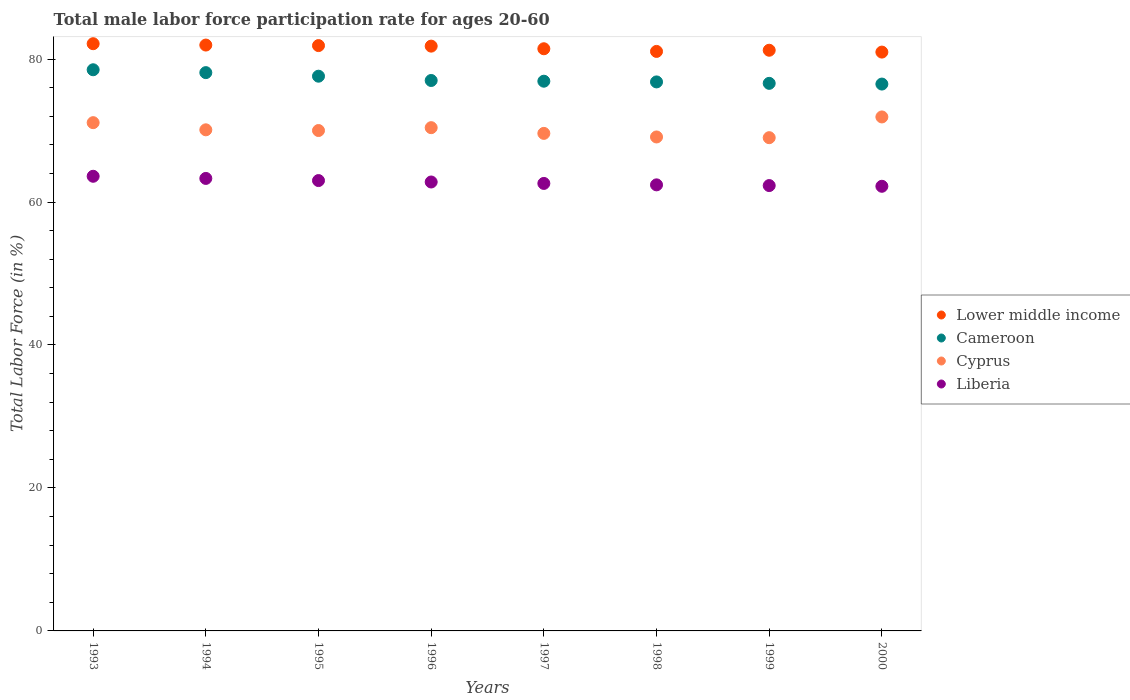What is the male labor force participation rate in Cyprus in 1996?
Make the answer very short. 70.4. Across all years, what is the maximum male labor force participation rate in Cyprus?
Provide a short and direct response. 71.9. Across all years, what is the minimum male labor force participation rate in Cyprus?
Offer a terse response. 69. What is the total male labor force participation rate in Liberia in the graph?
Provide a short and direct response. 502.2. What is the difference between the male labor force participation rate in Cyprus in 1996 and that in 1997?
Your answer should be compact. 0.8. What is the average male labor force participation rate in Cyprus per year?
Give a very brief answer. 70.15. In the year 1993, what is the difference between the male labor force participation rate in Cyprus and male labor force participation rate in Liberia?
Keep it short and to the point. 7.5. In how many years, is the male labor force participation rate in Lower middle income greater than 20 %?
Your answer should be compact. 8. What is the ratio of the male labor force participation rate in Cyprus in 1995 to that in 2000?
Ensure brevity in your answer.  0.97. Is the male labor force participation rate in Cyprus in 1996 less than that in 1998?
Your answer should be very brief. No. Is the difference between the male labor force participation rate in Cyprus in 1997 and 1998 greater than the difference between the male labor force participation rate in Liberia in 1997 and 1998?
Offer a very short reply. Yes. What is the difference between the highest and the second highest male labor force participation rate in Liberia?
Your answer should be very brief. 0.3. What is the difference between the highest and the lowest male labor force participation rate in Cameroon?
Offer a very short reply. 2. Is the sum of the male labor force participation rate in Liberia in 1993 and 1998 greater than the maximum male labor force participation rate in Cyprus across all years?
Provide a succinct answer. Yes. Does the male labor force participation rate in Lower middle income monotonically increase over the years?
Your answer should be compact. No. Is the male labor force participation rate in Liberia strictly greater than the male labor force participation rate in Cameroon over the years?
Your answer should be very brief. No. Is the male labor force participation rate in Lower middle income strictly less than the male labor force participation rate in Liberia over the years?
Make the answer very short. No. How many dotlines are there?
Provide a short and direct response. 4. Does the graph contain any zero values?
Give a very brief answer. No. Does the graph contain grids?
Keep it short and to the point. No. How many legend labels are there?
Ensure brevity in your answer.  4. What is the title of the graph?
Your answer should be compact. Total male labor force participation rate for ages 20-60. Does "Kuwait" appear as one of the legend labels in the graph?
Your answer should be very brief. No. What is the label or title of the X-axis?
Provide a succinct answer. Years. What is the Total Labor Force (in %) of Lower middle income in 1993?
Provide a short and direct response. 82.15. What is the Total Labor Force (in %) of Cameroon in 1993?
Your answer should be very brief. 78.5. What is the Total Labor Force (in %) in Cyprus in 1993?
Provide a short and direct response. 71.1. What is the Total Labor Force (in %) in Liberia in 1993?
Provide a succinct answer. 63.6. What is the Total Labor Force (in %) of Lower middle income in 1994?
Provide a short and direct response. 81.96. What is the Total Labor Force (in %) in Cameroon in 1994?
Your answer should be very brief. 78.1. What is the Total Labor Force (in %) of Cyprus in 1994?
Offer a terse response. 70.1. What is the Total Labor Force (in %) of Liberia in 1994?
Provide a short and direct response. 63.3. What is the Total Labor Force (in %) in Lower middle income in 1995?
Give a very brief answer. 81.88. What is the Total Labor Force (in %) in Cameroon in 1995?
Your answer should be compact. 77.6. What is the Total Labor Force (in %) in Lower middle income in 1996?
Offer a terse response. 81.81. What is the Total Labor Force (in %) of Cyprus in 1996?
Offer a very short reply. 70.4. What is the Total Labor Force (in %) in Liberia in 1996?
Your answer should be compact. 62.8. What is the Total Labor Force (in %) of Lower middle income in 1997?
Provide a short and direct response. 81.44. What is the Total Labor Force (in %) in Cameroon in 1997?
Your answer should be very brief. 76.9. What is the Total Labor Force (in %) in Cyprus in 1997?
Keep it short and to the point. 69.6. What is the Total Labor Force (in %) in Liberia in 1997?
Your answer should be very brief. 62.6. What is the Total Labor Force (in %) in Lower middle income in 1998?
Your answer should be compact. 81.07. What is the Total Labor Force (in %) in Cameroon in 1998?
Keep it short and to the point. 76.8. What is the Total Labor Force (in %) of Cyprus in 1998?
Make the answer very short. 69.1. What is the Total Labor Force (in %) in Liberia in 1998?
Provide a short and direct response. 62.4. What is the Total Labor Force (in %) of Lower middle income in 1999?
Your response must be concise. 81.23. What is the Total Labor Force (in %) of Cameroon in 1999?
Provide a succinct answer. 76.6. What is the Total Labor Force (in %) in Cyprus in 1999?
Give a very brief answer. 69. What is the Total Labor Force (in %) of Liberia in 1999?
Provide a succinct answer. 62.3. What is the Total Labor Force (in %) of Lower middle income in 2000?
Your answer should be very brief. 80.97. What is the Total Labor Force (in %) of Cameroon in 2000?
Offer a terse response. 76.5. What is the Total Labor Force (in %) in Cyprus in 2000?
Offer a very short reply. 71.9. What is the Total Labor Force (in %) in Liberia in 2000?
Your answer should be compact. 62.2. Across all years, what is the maximum Total Labor Force (in %) of Lower middle income?
Your answer should be very brief. 82.15. Across all years, what is the maximum Total Labor Force (in %) in Cameroon?
Your response must be concise. 78.5. Across all years, what is the maximum Total Labor Force (in %) of Cyprus?
Offer a terse response. 71.9. Across all years, what is the maximum Total Labor Force (in %) of Liberia?
Provide a succinct answer. 63.6. Across all years, what is the minimum Total Labor Force (in %) in Lower middle income?
Provide a succinct answer. 80.97. Across all years, what is the minimum Total Labor Force (in %) of Cameroon?
Ensure brevity in your answer.  76.5. Across all years, what is the minimum Total Labor Force (in %) in Cyprus?
Your response must be concise. 69. Across all years, what is the minimum Total Labor Force (in %) of Liberia?
Provide a short and direct response. 62.2. What is the total Total Labor Force (in %) of Lower middle income in the graph?
Your response must be concise. 652.5. What is the total Total Labor Force (in %) of Cameroon in the graph?
Offer a very short reply. 618. What is the total Total Labor Force (in %) in Cyprus in the graph?
Your answer should be compact. 561.2. What is the total Total Labor Force (in %) of Liberia in the graph?
Offer a very short reply. 502.2. What is the difference between the Total Labor Force (in %) of Lower middle income in 1993 and that in 1994?
Give a very brief answer. 0.19. What is the difference between the Total Labor Force (in %) in Cameroon in 1993 and that in 1994?
Keep it short and to the point. 0.4. What is the difference between the Total Labor Force (in %) of Cyprus in 1993 and that in 1994?
Ensure brevity in your answer.  1. What is the difference between the Total Labor Force (in %) in Lower middle income in 1993 and that in 1995?
Give a very brief answer. 0.26. What is the difference between the Total Labor Force (in %) of Cyprus in 1993 and that in 1995?
Keep it short and to the point. 1.1. What is the difference between the Total Labor Force (in %) in Liberia in 1993 and that in 1995?
Keep it short and to the point. 0.6. What is the difference between the Total Labor Force (in %) of Lower middle income in 1993 and that in 1996?
Give a very brief answer. 0.34. What is the difference between the Total Labor Force (in %) of Cameroon in 1993 and that in 1996?
Your response must be concise. 1.5. What is the difference between the Total Labor Force (in %) in Cyprus in 1993 and that in 1996?
Your response must be concise. 0.7. What is the difference between the Total Labor Force (in %) of Liberia in 1993 and that in 1996?
Ensure brevity in your answer.  0.8. What is the difference between the Total Labor Force (in %) in Lower middle income in 1993 and that in 1997?
Offer a very short reply. 0.71. What is the difference between the Total Labor Force (in %) in Lower middle income in 1993 and that in 1998?
Offer a terse response. 1.08. What is the difference between the Total Labor Force (in %) in Cameroon in 1993 and that in 1998?
Offer a very short reply. 1.7. What is the difference between the Total Labor Force (in %) of Cyprus in 1993 and that in 1998?
Provide a succinct answer. 2. What is the difference between the Total Labor Force (in %) in Liberia in 1993 and that in 1998?
Your answer should be compact. 1.2. What is the difference between the Total Labor Force (in %) in Lower middle income in 1993 and that in 1999?
Provide a succinct answer. 0.92. What is the difference between the Total Labor Force (in %) in Cameroon in 1993 and that in 1999?
Your answer should be compact. 1.9. What is the difference between the Total Labor Force (in %) of Cyprus in 1993 and that in 1999?
Provide a short and direct response. 2.1. What is the difference between the Total Labor Force (in %) in Lower middle income in 1993 and that in 2000?
Provide a succinct answer. 1.17. What is the difference between the Total Labor Force (in %) of Cyprus in 1993 and that in 2000?
Provide a short and direct response. -0.8. What is the difference between the Total Labor Force (in %) in Liberia in 1993 and that in 2000?
Offer a terse response. 1.4. What is the difference between the Total Labor Force (in %) of Lower middle income in 1994 and that in 1995?
Offer a very short reply. 0.07. What is the difference between the Total Labor Force (in %) in Liberia in 1994 and that in 1995?
Your answer should be compact. 0.3. What is the difference between the Total Labor Force (in %) in Lower middle income in 1994 and that in 1996?
Your answer should be very brief. 0.15. What is the difference between the Total Labor Force (in %) of Cameroon in 1994 and that in 1996?
Offer a very short reply. 1.1. What is the difference between the Total Labor Force (in %) in Lower middle income in 1994 and that in 1997?
Keep it short and to the point. 0.52. What is the difference between the Total Labor Force (in %) in Cyprus in 1994 and that in 1997?
Your answer should be compact. 0.5. What is the difference between the Total Labor Force (in %) of Lower middle income in 1994 and that in 1998?
Make the answer very short. 0.89. What is the difference between the Total Labor Force (in %) of Cyprus in 1994 and that in 1998?
Ensure brevity in your answer.  1. What is the difference between the Total Labor Force (in %) of Lower middle income in 1994 and that in 1999?
Your answer should be very brief. 0.73. What is the difference between the Total Labor Force (in %) in Cameroon in 1994 and that in 1999?
Provide a short and direct response. 1.5. What is the difference between the Total Labor Force (in %) of Lower middle income in 1994 and that in 2000?
Provide a succinct answer. 0.98. What is the difference between the Total Labor Force (in %) in Cyprus in 1994 and that in 2000?
Your answer should be very brief. -1.8. What is the difference between the Total Labor Force (in %) of Lower middle income in 1995 and that in 1996?
Offer a very short reply. 0.08. What is the difference between the Total Labor Force (in %) in Cyprus in 1995 and that in 1996?
Your response must be concise. -0.4. What is the difference between the Total Labor Force (in %) in Liberia in 1995 and that in 1996?
Your answer should be very brief. 0.2. What is the difference between the Total Labor Force (in %) of Lower middle income in 1995 and that in 1997?
Offer a terse response. 0.44. What is the difference between the Total Labor Force (in %) in Cameroon in 1995 and that in 1997?
Ensure brevity in your answer.  0.7. What is the difference between the Total Labor Force (in %) of Cyprus in 1995 and that in 1997?
Make the answer very short. 0.4. What is the difference between the Total Labor Force (in %) of Liberia in 1995 and that in 1997?
Provide a succinct answer. 0.4. What is the difference between the Total Labor Force (in %) of Lower middle income in 1995 and that in 1998?
Ensure brevity in your answer.  0.82. What is the difference between the Total Labor Force (in %) in Cyprus in 1995 and that in 1998?
Ensure brevity in your answer.  0.9. What is the difference between the Total Labor Force (in %) in Liberia in 1995 and that in 1998?
Your answer should be very brief. 0.6. What is the difference between the Total Labor Force (in %) in Lower middle income in 1995 and that in 1999?
Keep it short and to the point. 0.65. What is the difference between the Total Labor Force (in %) of Cameroon in 1995 and that in 1999?
Give a very brief answer. 1. What is the difference between the Total Labor Force (in %) of Liberia in 1995 and that in 1999?
Keep it short and to the point. 0.7. What is the difference between the Total Labor Force (in %) of Lower middle income in 1995 and that in 2000?
Your answer should be very brief. 0.91. What is the difference between the Total Labor Force (in %) of Cameroon in 1995 and that in 2000?
Make the answer very short. 1.1. What is the difference between the Total Labor Force (in %) of Cyprus in 1995 and that in 2000?
Your answer should be compact. -1.9. What is the difference between the Total Labor Force (in %) of Lower middle income in 1996 and that in 1997?
Your answer should be very brief. 0.37. What is the difference between the Total Labor Force (in %) of Liberia in 1996 and that in 1997?
Ensure brevity in your answer.  0.2. What is the difference between the Total Labor Force (in %) of Lower middle income in 1996 and that in 1998?
Make the answer very short. 0.74. What is the difference between the Total Labor Force (in %) in Cameroon in 1996 and that in 1998?
Provide a succinct answer. 0.2. What is the difference between the Total Labor Force (in %) in Cyprus in 1996 and that in 1998?
Offer a very short reply. 1.3. What is the difference between the Total Labor Force (in %) in Lower middle income in 1996 and that in 1999?
Provide a succinct answer. 0.58. What is the difference between the Total Labor Force (in %) of Cameroon in 1996 and that in 1999?
Offer a very short reply. 0.4. What is the difference between the Total Labor Force (in %) in Cyprus in 1996 and that in 1999?
Ensure brevity in your answer.  1.4. What is the difference between the Total Labor Force (in %) of Liberia in 1996 and that in 1999?
Make the answer very short. 0.5. What is the difference between the Total Labor Force (in %) in Lower middle income in 1996 and that in 2000?
Your response must be concise. 0.83. What is the difference between the Total Labor Force (in %) in Liberia in 1996 and that in 2000?
Offer a very short reply. 0.6. What is the difference between the Total Labor Force (in %) in Lower middle income in 1997 and that in 1998?
Offer a very short reply. 0.37. What is the difference between the Total Labor Force (in %) of Cameroon in 1997 and that in 1998?
Your answer should be very brief. 0.1. What is the difference between the Total Labor Force (in %) in Cyprus in 1997 and that in 1998?
Give a very brief answer. 0.5. What is the difference between the Total Labor Force (in %) in Lower middle income in 1997 and that in 1999?
Give a very brief answer. 0.21. What is the difference between the Total Labor Force (in %) in Cameroon in 1997 and that in 1999?
Keep it short and to the point. 0.3. What is the difference between the Total Labor Force (in %) of Liberia in 1997 and that in 1999?
Give a very brief answer. 0.3. What is the difference between the Total Labor Force (in %) of Lower middle income in 1997 and that in 2000?
Ensure brevity in your answer.  0.47. What is the difference between the Total Labor Force (in %) of Cameroon in 1997 and that in 2000?
Keep it short and to the point. 0.4. What is the difference between the Total Labor Force (in %) in Cyprus in 1997 and that in 2000?
Provide a succinct answer. -2.3. What is the difference between the Total Labor Force (in %) of Lower middle income in 1998 and that in 1999?
Ensure brevity in your answer.  -0.16. What is the difference between the Total Labor Force (in %) in Lower middle income in 1998 and that in 2000?
Keep it short and to the point. 0.09. What is the difference between the Total Labor Force (in %) of Cyprus in 1998 and that in 2000?
Offer a very short reply. -2.8. What is the difference between the Total Labor Force (in %) of Liberia in 1998 and that in 2000?
Keep it short and to the point. 0.2. What is the difference between the Total Labor Force (in %) in Lower middle income in 1999 and that in 2000?
Offer a very short reply. 0.26. What is the difference between the Total Labor Force (in %) in Cyprus in 1999 and that in 2000?
Make the answer very short. -2.9. What is the difference between the Total Labor Force (in %) of Lower middle income in 1993 and the Total Labor Force (in %) of Cameroon in 1994?
Offer a terse response. 4.05. What is the difference between the Total Labor Force (in %) in Lower middle income in 1993 and the Total Labor Force (in %) in Cyprus in 1994?
Ensure brevity in your answer.  12.05. What is the difference between the Total Labor Force (in %) of Lower middle income in 1993 and the Total Labor Force (in %) of Liberia in 1994?
Ensure brevity in your answer.  18.85. What is the difference between the Total Labor Force (in %) in Cameroon in 1993 and the Total Labor Force (in %) in Cyprus in 1994?
Your answer should be compact. 8.4. What is the difference between the Total Labor Force (in %) of Lower middle income in 1993 and the Total Labor Force (in %) of Cameroon in 1995?
Give a very brief answer. 4.55. What is the difference between the Total Labor Force (in %) in Lower middle income in 1993 and the Total Labor Force (in %) in Cyprus in 1995?
Keep it short and to the point. 12.15. What is the difference between the Total Labor Force (in %) in Lower middle income in 1993 and the Total Labor Force (in %) in Liberia in 1995?
Your response must be concise. 19.15. What is the difference between the Total Labor Force (in %) in Cameroon in 1993 and the Total Labor Force (in %) in Liberia in 1995?
Make the answer very short. 15.5. What is the difference between the Total Labor Force (in %) in Cyprus in 1993 and the Total Labor Force (in %) in Liberia in 1995?
Your answer should be compact. 8.1. What is the difference between the Total Labor Force (in %) in Lower middle income in 1993 and the Total Labor Force (in %) in Cameroon in 1996?
Ensure brevity in your answer.  5.15. What is the difference between the Total Labor Force (in %) of Lower middle income in 1993 and the Total Labor Force (in %) of Cyprus in 1996?
Offer a very short reply. 11.75. What is the difference between the Total Labor Force (in %) in Lower middle income in 1993 and the Total Labor Force (in %) in Liberia in 1996?
Your answer should be very brief. 19.35. What is the difference between the Total Labor Force (in %) in Cyprus in 1993 and the Total Labor Force (in %) in Liberia in 1996?
Provide a succinct answer. 8.3. What is the difference between the Total Labor Force (in %) of Lower middle income in 1993 and the Total Labor Force (in %) of Cameroon in 1997?
Offer a very short reply. 5.25. What is the difference between the Total Labor Force (in %) in Lower middle income in 1993 and the Total Labor Force (in %) in Cyprus in 1997?
Offer a terse response. 12.55. What is the difference between the Total Labor Force (in %) in Lower middle income in 1993 and the Total Labor Force (in %) in Liberia in 1997?
Your response must be concise. 19.55. What is the difference between the Total Labor Force (in %) in Lower middle income in 1993 and the Total Labor Force (in %) in Cameroon in 1998?
Provide a short and direct response. 5.35. What is the difference between the Total Labor Force (in %) of Lower middle income in 1993 and the Total Labor Force (in %) of Cyprus in 1998?
Your answer should be very brief. 13.05. What is the difference between the Total Labor Force (in %) of Lower middle income in 1993 and the Total Labor Force (in %) of Liberia in 1998?
Your response must be concise. 19.75. What is the difference between the Total Labor Force (in %) of Cameroon in 1993 and the Total Labor Force (in %) of Cyprus in 1998?
Your answer should be very brief. 9.4. What is the difference between the Total Labor Force (in %) of Cameroon in 1993 and the Total Labor Force (in %) of Liberia in 1998?
Your answer should be very brief. 16.1. What is the difference between the Total Labor Force (in %) of Cyprus in 1993 and the Total Labor Force (in %) of Liberia in 1998?
Offer a terse response. 8.7. What is the difference between the Total Labor Force (in %) in Lower middle income in 1993 and the Total Labor Force (in %) in Cameroon in 1999?
Ensure brevity in your answer.  5.55. What is the difference between the Total Labor Force (in %) in Lower middle income in 1993 and the Total Labor Force (in %) in Cyprus in 1999?
Provide a short and direct response. 13.15. What is the difference between the Total Labor Force (in %) of Lower middle income in 1993 and the Total Labor Force (in %) of Liberia in 1999?
Offer a very short reply. 19.85. What is the difference between the Total Labor Force (in %) of Cyprus in 1993 and the Total Labor Force (in %) of Liberia in 1999?
Keep it short and to the point. 8.8. What is the difference between the Total Labor Force (in %) of Lower middle income in 1993 and the Total Labor Force (in %) of Cameroon in 2000?
Offer a very short reply. 5.65. What is the difference between the Total Labor Force (in %) in Lower middle income in 1993 and the Total Labor Force (in %) in Cyprus in 2000?
Offer a very short reply. 10.25. What is the difference between the Total Labor Force (in %) of Lower middle income in 1993 and the Total Labor Force (in %) of Liberia in 2000?
Your answer should be very brief. 19.95. What is the difference between the Total Labor Force (in %) of Cameroon in 1993 and the Total Labor Force (in %) of Cyprus in 2000?
Your response must be concise. 6.6. What is the difference between the Total Labor Force (in %) of Cameroon in 1993 and the Total Labor Force (in %) of Liberia in 2000?
Make the answer very short. 16.3. What is the difference between the Total Labor Force (in %) of Cyprus in 1993 and the Total Labor Force (in %) of Liberia in 2000?
Ensure brevity in your answer.  8.9. What is the difference between the Total Labor Force (in %) of Lower middle income in 1994 and the Total Labor Force (in %) of Cameroon in 1995?
Offer a very short reply. 4.36. What is the difference between the Total Labor Force (in %) of Lower middle income in 1994 and the Total Labor Force (in %) of Cyprus in 1995?
Provide a short and direct response. 11.96. What is the difference between the Total Labor Force (in %) of Lower middle income in 1994 and the Total Labor Force (in %) of Liberia in 1995?
Give a very brief answer. 18.96. What is the difference between the Total Labor Force (in %) in Cameroon in 1994 and the Total Labor Force (in %) in Cyprus in 1995?
Ensure brevity in your answer.  8.1. What is the difference between the Total Labor Force (in %) in Lower middle income in 1994 and the Total Labor Force (in %) in Cameroon in 1996?
Offer a very short reply. 4.96. What is the difference between the Total Labor Force (in %) in Lower middle income in 1994 and the Total Labor Force (in %) in Cyprus in 1996?
Give a very brief answer. 11.56. What is the difference between the Total Labor Force (in %) of Lower middle income in 1994 and the Total Labor Force (in %) of Liberia in 1996?
Offer a terse response. 19.16. What is the difference between the Total Labor Force (in %) of Cyprus in 1994 and the Total Labor Force (in %) of Liberia in 1996?
Your response must be concise. 7.3. What is the difference between the Total Labor Force (in %) in Lower middle income in 1994 and the Total Labor Force (in %) in Cameroon in 1997?
Your response must be concise. 5.06. What is the difference between the Total Labor Force (in %) of Lower middle income in 1994 and the Total Labor Force (in %) of Cyprus in 1997?
Provide a short and direct response. 12.36. What is the difference between the Total Labor Force (in %) in Lower middle income in 1994 and the Total Labor Force (in %) in Liberia in 1997?
Your response must be concise. 19.36. What is the difference between the Total Labor Force (in %) in Cyprus in 1994 and the Total Labor Force (in %) in Liberia in 1997?
Make the answer very short. 7.5. What is the difference between the Total Labor Force (in %) of Lower middle income in 1994 and the Total Labor Force (in %) of Cameroon in 1998?
Make the answer very short. 5.16. What is the difference between the Total Labor Force (in %) of Lower middle income in 1994 and the Total Labor Force (in %) of Cyprus in 1998?
Your answer should be compact. 12.86. What is the difference between the Total Labor Force (in %) of Lower middle income in 1994 and the Total Labor Force (in %) of Liberia in 1998?
Offer a very short reply. 19.56. What is the difference between the Total Labor Force (in %) in Cameroon in 1994 and the Total Labor Force (in %) in Cyprus in 1998?
Ensure brevity in your answer.  9. What is the difference between the Total Labor Force (in %) in Lower middle income in 1994 and the Total Labor Force (in %) in Cameroon in 1999?
Offer a very short reply. 5.36. What is the difference between the Total Labor Force (in %) of Lower middle income in 1994 and the Total Labor Force (in %) of Cyprus in 1999?
Provide a short and direct response. 12.96. What is the difference between the Total Labor Force (in %) in Lower middle income in 1994 and the Total Labor Force (in %) in Liberia in 1999?
Provide a short and direct response. 19.66. What is the difference between the Total Labor Force (in %) in Cameroon in 1994 and the Total Labor Force (in %) in Liberia in 1999?
Make the answer very short. 15.8. What is the difference between the Total Labor Force (in %) of Cyprus in 1994 and the Total Labor Force (in %) of Liberia in 1999?
Ensure brevity in your answer.  7.8. What is the difference between the Total Labor Force (in %) in Lower middle income in 1994 and the Total Labor Force (in %) in Cameroon in 2000?
Your response must be concise. 5.46. What is the difference between the Total Labor Force (in %) of Lower middle income in 1994 and the Total Labor Force (in %) of Cyprus in 2000?
Provide a short and direct response. 10.06. What is the difference between the Total Labor Force (in %) of Lower middle income in 1994 and the Total Labor Force (in %) of Liberia in 2000?
Offer a very short reply. 19.76. What is the difference between the Total Labor Force (in %) of Cameroon in 1994 and the Total Labor Force (in %) of Cyprus in 2000?
Provide a short and direct response. 6.2. What is the difference between the Total Labor Force (in %) in Cameroon in 1994 and the Total Labor Force (in %) in Liberia in 2000?
Your response must be concise. 15.9. What is the difference between the Total Labor Force (in %) in Cyprus in 1994 and the Total Labor Force (in %) in Liberia in 2000?
Provide a short and direct response. 7.9. What is the difference between the Total Labor Force (in %) of Lower middle income in 1995 and the Total Labor Force (in %) of Cameroon in 1996?
Provide a succinct answer. 4.88. What is the difference between the Total Labor Force (in %) in Lower middle income in 1995 and the Total Labor Force (in %) in Cyprus in 1996?
Provide a succinct answer. 11.48. What is the difference between the Total Labor Force (in %) in Lower middle income in 1995 and the Total Labor Force (in %) in Liberia in 1996?
Keep it short and to the point. 19.08. What is the difference between the Total Labor Force (in %) in Cyprus in 1995 and the Total Labor Force (in %) in Liberia in 1996?
Your answer should be very brief. 7.2. What is the difference between the Total Labor Force (in %) in Lower middle income in 1995 and the Total Labor Force (in %) in Cameroon in 1997?
Your answer should be very brief. 4.98. What is the difference between the Total Labor Force (in %) in Lower middle income in 1995 and the Total Labor Force (in %) in Cyprus in 1997?
Ensure brevity in your answer.  12.28. What is the difference between the Total Labor Force (in %) in Lower middle income in 1995 and the Total Labor Force (in %) in Liberia in 1997?
Your answer should be very brief. 19.28. What is the difference between the Total Labor Force (in %) of Cameroon in 1995 and the Total Labor Force (in %) of Liberia in 1997?
Your answer should be compact. 15. What is the difference between the Total Labor Force (in %) in Cyprus in 1995 and the Total Labor Force (in %) in Liberia in 1997?
Ensure brevity in your answer.  7.4. What is the difference between the Total Labor Force (in %) of Lower middle income in 1995 and the Total Labor Force (in %) of Cameroon in 1998?
Keep it short and to the point. 5.08. What is the difference between the Total Labor Force (in %) in Lower middle income in 1995 and the Total Labor Force (in %) in Cyprus in 1998?
Your answer should be very brief. 12.78. What is the difference between the Total Labor Force (in %) in Lower middle income in 1995 and the Total Labor Force (in %) in Liberia in 1998?
Keep it short and to the point. 19.48. What is the difference between the Total Labor Force (in %) in Cameroon in 1995 and the Total Labor Force (in %) in Cyprus in 1998?
Keep it short and to the point. 8.5. What is the difference between the Total Labor Force (in %) in Lower middle income in 1995 and the Total Labor Force (in %) in Cameroon in 1999?
Give a very brief answer. 5.28. What is the difference between the Total Labor Force (in %) of Lower middle income in 1995 and the Total Labor Force (in %) of Cyprus in 1999?
Keep it short and to the point. 12.88. What is the difference between the Total Labor Force (in %) in Lower middle income in 1995 and the Total Labor Force (in %) in Liberia in 1999?
Your answer should be very brief. 19.58. What is the difference between the Total Labor Force (in %) of Cameroon in 1995 and the Total Labor Force (in %) of Cyprus in 1999?
Give a very brief answer. 8.6. What is the difference between the Total Labor Force (in %) of Cameroon in 1995 and the Total Labor Force (in %) of Liberia in 1999?
Give a very brief answer. 15.3. What is the difference between the Total Labor Force (in %) of Lower middle income in 1995 and the Total Labor Force (in %) of Cameroon in 2000?
Provide a short and direct response. 5.38. What is the difference between the Total Labor Force (in %) of Lower middle income in 1995 and the Total Labor Force (in %) of Cyprus in 2000?
Ensure brevity in your answer.  9.98. What is the difference between the Total Labor Force (in %) in Lower middle income in 1995 and the Total Labor Force (in %) in Liberia in 2000?
Provide a short and direct response. 19.68. What is the difference between the Total Labor Force (in %) in Cameroon in 1995 and the Total Labor Force (in %) in Cyprus in 2000?
Provide a succinct answer. 5.7. What is the difference between the Total Labor Force (in %) of Cameroon in 1995 and the Total Labor Force (in %) of Liberia in 2000?
Ensure brevity in your answer.  15.4. What is the difference between the Total Labor Force (in %) in Lower middle income in 1996 and the Total Labor Force (in %) in Cameroon in 1997?
Your answer should be compact. 4.91. What is the difference between the Total Labor Force (in %) of Lower middle income in 1996 and the Total Labor Force (in %) of Cyprus in 1997?
Your response must be concise. 12.21. What is the difference between the Total Labor Force (in %) of Lower middle income in 1996 and the Total Labor Force (in %) of Liberia in 1997?
Your answer should be compact. 19.21. What is the difference between the Total Labor Force (in %) of Cameroon in 1996 and the Total Labor Force (in %) of Cyprus in 1997?
Ensure brevity in your answer.  7.4. What is the difference between the Total Labor Force (in %) of Cameroon in 1996 and the Total Labor Force (in %) of Liberia in 1997?
Offer a terse response. 14.4. What is the difference between the Total Labor Force (in %) of Cyprus in 1996 and the Total Labor Force (in %) of Liberia in 1997?
Provide a succinct answer. 7.8. What is the difference between the Total Labor Force (in %) of Lower middle income in 1996 and the Total Labor Force (in %) of Cameroon in 1998?
Provide a succinct answer. 5.01. What is the difference between the Total Labor Force (in %) of Lower middle income in 1996 and the Total Labor Force (in %) of Cyprus in 1998?
Give a very brief answer. 12.71. What is the difference between the Total Labor Force (in %) in Lower middle income in 1996 and the Total Labor Force (in %) in Liberia in 1998?
Offer a terse response. 19.41. What is the difference between the Total Labor Force (in %) of Cameroon in 1996 and the Total Labor Force (in %) of Cyprus in 1998?
Provide a short and direct response. 7.9. What is the difference between the Total Labor Force (in %) of Lower middle income in 1996 and the Total Labor Force (in %) of Cameroon in 1999?
Your answer should be very brief. 5.21. What is the difference between the Total Labor Force (in %) of Lower middle income in 1996 and the Total Labor Force (in %) of Cyprus in 1999?
Provide a succinct answer. 12.81. What is the difference between the Total Labor Force (in %) in Lower middle income in 1996 and the Total Labor Force (in %) in Liberia in 1999?
Ensure brevity in your answer.  19.51. What is the difference between the Total Labor Force (in %) in Cameroon in 1996 and the Total Labor Force (in %) in Cyprus in 1999?
Give a very brief answer. 8. What is the difference between the Total Labor Force (in %) of Cameroon in 1996 and the Total Labor Force (in %) of Liberia in 1999?
Your response must be concise. 14.7. What is the difference between the Total Labor Force (in %) of Cyprus in 1996 and the Total Labor Force (in %) of Liberia in 1999?
Keep it short and to the point. 8.1. What is the difference between the Total Labor Force (in %) in Lower middle income in 1996 and the Total Labor Force (in %) in Cameroon in 2000?
Your answer should be very brief. 5.31. What is the difference between the Total Labor Force (in %) of Lower middle income in 1996 and the Total Labor Force (in %) of Cyprus in 2000?
Your answer should be very brief. 9.91. What is the difference between the Total Labor Force (in %) of Lower middle income in 1996 and the Total Labor Force (in %) of Liberia in 2000?
Keep it short and to the point. 19.61. What is the difference between the Total Labor Force (in %) of Cameroon in 1996 and the Total Labor Force (in %) of Cyprus in 2000?
Ensure brevity in your answer.  5.1. What is the difference between the Total Labor Force (in %) in Cameroon in 1996 and the Total Labor Force (in %) in Liberia in 2000?
Your answer should be compact. 14.8. What is the difference between the Total Labor Force (in %) in Cyprus in 1996 and the Total Labor Force (in %) in Liberia in 2000?
Keep it short and to the point. 8.2. What is the difference between the Total Labor Force (in %) in Lower middle income in 1997 and the Total Labor Force (in %) in Cameroon in 1998?
Your answer should be very brief. 4.64. What is the difference between the Total Labor Force (in %) of Lower middle income in 1997 and the Total Labor Force (in %) of Cyprus in 1998?
Offer a very short reply. 12.34. What is the difference between the Total Labor Force (in %) of Lower middle income in 1997 and the Total Labor Force (in %) of Liberia in 1998?
Ensure brevity in your answer.  19.04. What is the difference between the Total Labor Force (in %) of Cameroon in 1997 and the Total Labor Force (in %) of Cyprus in 1998?
Offer a very short reply. 7.8. What is the difference between the Total Labor Force (in %) of Cameroon in 1997 and the Total Labor Force (in %) of Liberia in 1998?
Make the answer very short. 14.5. What is the difference between the Total Labor Force (in %) of Lower middle income in 1997 and the Total Labor Force (in %) of Cameroon in 1999?
Offer a very short reply. 4.84. What is the difference between the Total Labor Force (in %) of Lower middle income in 1997 and the Total Labor Force (in %) of Cyprus in 1999?
Your response must be concise. 12.44. What is the difference between the Total Labor Force (in %) in Lower middle income in 1997 and the Total Labor Force (in %) in Liberia in 1999?
Offer a terse response. 19.14. What is the difference between the Total Labor Force (in %) in Cameroon in 1997 and the Total Labor Force (in %) in Liberia in 1999?
Your answer should be compact. 14.6. What is the difference between the Total Labor Force (in %) in Lower middle income in 1997 and the Total Labor Force (in %) in Cameroon in 2000?
Give a very brief answer. 4.94. What is the difference between the Total Labor Force (in %) in Lower middle income in 1997 and the Total Labor Force (in %) in Cyprus in 2000?
Your response must be concise. 9.54. What is the difference between the Total Labor Force (in %) in Lower middle income in 1997 and the Total Labor Force (in %) in Liberia in 2000?
Offer a very short reply. 19.24. What is the difference between the Total Labor Force (in %) of Cameroon in 1997 and the Total Labor Force (in %) of Liberia in 2000?
Make the answer very short. 14.7. What is the difference between the Total Labor Force (in %) in Cyprus in 1997 and the Total Labor Force (in %) in Liberia in 2000?
Your response must be concise. 7.4. What is the difference between the Total Labor Force (in %) of Lower middle income in 1998 and the Total Labor Force (in %) of Cameroon in 1999?
Your answer should be very brief. 4.47. What is the difference between the Total Labor Force (in %) of Lower middle income in 1998 and the Total Labor Force (in %) of Cyprus in 1999?
Give a very brief answer. 12.07. What is the difference between the Total Labor Force (in %) of Lower middle income in 1998 and the Total Labor Force (in %) of Liberia in 1999?
Offer a terse response. 18.77. What is the difference between the Total Labor Force (in %) of Cameroon in 1998 and the Total Labor Force (in %) of Cyprus in 1999?
Provide a short and direct response. 7.8. What is the difference between the Total Labor Force (in %) of Lower middle income in 1998 and the Total Labor Force (in %) of Cameroon in 2000?
Provide a succinct answer. 4.57. What is the difference between the Total Labor Force (in %) of Lower middle income in 1998 and the Total Labor Force (in %) of Cyprus in 2000?
Give a very brief answer. 9.17. What is the difference between the Total Labor Force (in %) in Lower middle income in 1998 and the Total Labor Force (in %) in Liberia in 2000?
Keep it short and to the point. 18.87. What is the difference between the Total Labor Force (in %) of Cameroon in 1998 and the Total Labor Force (in %) of Cyprus in 2000?
Your response must be concise. 4.9. What is the difference between the Total Labor Force (in %) in Cameroon in 1998 and the Total Labor Force (in %) in Liberia in 2000?
Keep it short and to the point. 14.6. What is the difference between the Total Labor Force (in %) of Lower middle income in 1999 and the Total Labor Force (in %) of Cameroon in 2000?
Provide a succinct answer. 4.73. What is the difference between the Total Labor Force (in %) in Lower middle income in 1999 and the Total Labor Force (in %) in Cyprus in 2000?
Your answer should be compact. 9.33. What is the difference between the Total Labor Force (in %) in Lower middle income in 1999 and the Total Labor Force (in %) in Liberia in 2000?
Offer a terse response. 19.03. What is the difference between the Total Labor Force (in %) of Cameroon in 1999 and the Total Labor Force (in %) of Cyprus in 2000?
Keep it short and to the point. 4.7. What is the difference between the Total Labor Force (in %) in Cyprus in 1999 and the Total Labor Force (in %) in Liberia in 2000?
Make the answer very short. 6.8. What is the average Total Labor Force (in %) in Lower middle income per year?
Offer a terse response. 81.56. What is the average Total Labor Force (in %) of Cameroon per year?
Offer a terse response. 77.25. What is the average Total Labor Force (in %) in Cyprus per year?
Keep it short and to the point. 70.15. What is the average Total Labor Force (in %) of Liberia per year?
Give a very brief answer. 62.77. In the year 1993, what is the difference between the Total Labor Force (in %) of Lower middle income and Total Labor Force (in %) of Cameroon?
Keep it short and to the point. 3.65. In the year 1993, what is the difference between the Total Labor Force (in %) in Lower middle income and Total Labor Force (in %) in Cyprus?
Your answer should be compact. 11.05. In the year 1993, what is the difference between the Total Labor Force (in %) in Lower middle income and Total Labor Force (in %) in Liberia?
Ensure brevity in your answer.  18.55. In the year 1993, what is the difference between the Total Labor Force (in %) in Cameroon and Total Labor Force (in %) in Cyprus?
Keep it short and to the point. 7.4. In the year 1993, what is the difference between the Total Labor Force (in %) in Cameroon and Total Labor Force (in %) in Liberia?
Offer a very short reply. 14.9. In the year 1993, what is the difference between the Total Labor Force (in %) in Cyprus and Total Labor Force (in %) in Liberia?
Offer a terse response. 7.5. In the year 1994, what is the difference between the Total Labor Force (in %) of Lower middle income and Total Labor Force (in %) of Cameroon?
Give a very brief answer. 3.86. In the year 1994, what is the difference between the Total Labor Force (in %) in Lower middle income and Total Labor Force (in %) in Cyprus?
Your answer should be compact. 11.86. In the year 1994, what is the difference between the Total Labor Force (in %) of Lower middle income and Total Labor Force (in %) of Liberia?
Offer a very short reply. 18.66. In the year 1994, what is the difference between the Total Labor Force (in %) in Cyprus and Total Labor Force (in %) in Liberia?
Provide a short and direct response. 6.8. In the year 1995, what is the difference between the Total Labor Force (in %) in Lower middle income and Total Labor Force (in %) in Cameroon?
Keep it short and to the point. 4.28. In the year 1995, what is the difference between the Total Labor Force (in %) in Lower middle income and Total Labor Force (in %) in Cyprus?
Your answer should be very brief. 11.88. In the year 1995, what is the difference between the Total Labor Force (in %) of Lower middle income and Total Labor Force (in %) of Liberia?
Provide a short and direct response. 18.88. In the year 1995, what is the difference between the Total Labor Force (in %) in Cameroon and Total Labor Force (in %) in Liberia?
Give a very brief answer. 14.6. In the year 1996, what is the difference between the Total Labor Force (in %) of Lower middle income and Total Labor Force (in %) of Cameroon?
Your answer should be compact. 4.81. In the year 1996, what is the difference between the Total Labor Force (in %) in Lower middle income and Total Labor Force (in %) in Cyprus?
Keep it short and to the point. 11.41. In the year 1996, what is the difference between the Total Labor Force (in %) in Lower middle income and Total Labor Force (in %) in Liberia?
Give a very brief answer. 19.01. In the year 1996, what is the difference between the Total Labor Force (in %) of Cyprus and Total Labor Force (in %) of Liberia?
Your answer should be very brief. 7.6. In the year 1997, what is the difference between the Total Labor Force (in %) of Lower middle income and Total Labor Force (in %) of Cameroon?
Make the answer very short. 4.54. In the year 1997, what is the difference between the Total Labor Force (in %) in Lower middle income and Total Labor Force (in %) in Cyprus?
Offer a terse response. 11.84. In the year 1997, what is the difference between the Total Labor Force (in %) in Lower middle income and Total Labor Force (in %) in Liberia?
Ensure brevity in your answer.  18.84. In the year 1997, what is the difference between the Total Labor Force (in %) in Cameroon and Total Labor Force (in %) in Cyprus?
Your answer should be very brief. 7.3. In the year 1997, what is the difference between the Total Labor Force (in %) of Cameroon and Total Labor Force (in %) of Liberia?
Offer a terse response. 14.3. In the year 1997, what is the difference between the Total Labor Force (in %) in Cyprus and Total Labor Force (in %) in Liberia?
Your answer should be compact. 7. In the year 1998, what is the difference between the Total Labor Force (in %) of Lower middle income and Total Labor Force (in %) of Cameroon?
Your response must be concise. 4.27. In the year 1998, what is the difference between the Total Labor Force (in %) in Lower middle income and Total Labor Force (in %) in Cyprus?
Make the answer very short. 11.97. In the year 1998, what is the difference between the Total Labor Force (in %) of Lower middle income and Total Labor Force (in %) of Liberia?
Offer a terse response. 18.67. In the year 1998, what is the difference between the Total Labor Force (in %) in Cyprus and Total Labor Force (in %) in Liberia?
Give a very brief answer. 6.7. In the year 1999, what is the difference between the Total Labor Force (in %) in Lower middle income and Total Labor Force (in %) in Cameroon?
Your answer should be very brief. 4.63. In the year 1999, what is the difference between the Total Labor Force (in %) in Lower middle income and Total Labor Force (in %) in Cyprus?
Offer a very short reply. 12.23. In the year 1999, what is the difference between the Total Labor Force (in %) of Lower middle income and Total Labor Force (in %) of Liberia?
Offer a very short reply. 18.93. In the year 1999, what is the difference between the Total Labor Force (in %) of Cameroon and Total Labor Force (in %) of Liberia?
Provide a short and direct response. 14.3. In the year 1999, what is the difference between the Total Labor Force (in %) of Cyprus and Total Labor Force (in %) of Liberia?
Offer a terse response. 6.7. In the year 2000, what is the difference between the Total Labor Force (in %) in Lower middle income and Total Labor Force (in %) in Cameroon?
Your response must be concise. 4.47. In the year 2000, what is the difference between the Total Labor Force (in %) in Lower middle income and Total Labor Force (in %) in Cyprus?
Your answer should be very brief. 9.07. In the year 2000, what is the difference between the Total Labor Force (in %) in Lower middle income and Total Labor Force (in %) in Liberia?
Keep it short and to the point. 18.77. What is the ratio of the Total Labor Force (in %) of Lower middle income in 1993 to that in 1994?
Your answer should be compact. 1. What is the ratio of the Total Labor Force (in %) of Cyprus in 1993 to that in 1994?
Make the answer very short. 1.01. What is the ratio of the Total Labor Force (in %) in Liberia in 1993 to that in 1994?
Your answer should be compact. 1. What is the ratio of the Total Labor Force (in %) of Cameroon in 1993 to that in 1995?
Ensure brevity in your answer.  1.01. What is the ratio of the Total Labor Force (in %) of Cyprus in 1993 to that in 1995?
Provide a short and direct response. 1.02. What is the ratio of the Total Labor Force (in %) in Liberia in 1993 to that in 1995?
Keep it short and to the point. 1.01. What is the ratio of the Total Labor Force (in %) of Lower middle income in 1993 to that in 1996?
Your answer should be compact. 1. What is the ratio of the Total Labor Force (in %) of Cameroon in 1993 to that in 1996?
Provide a succinct answer. 1.02. What is the ratio of the Total Labor Force (in %) in Cyprus in 1993 to that in 1996?
Give a very brief answer. 1.01. What is the ratio of the Total Labor Force (in %) of Liberia in 1993 to that in 1996?
Make the answer very short. 1.01. What is the ratio of the Total Labor Force (in %) in Lower middle income in 1993 to that in 1997?
Offer a terse response. 1.01. What is the ratio of the Total Labor Force (in %) in Cameroon in 1993 to that in 1997?
Provide a succinct answer. 1.02. What is the ratio of the Total Labor Force (in %) of Cyprus in 1993 to that in 1997?
Provide a short and direct response. 1.02. What is the ratio of the Total Labor Force (in %) of Lower middle income in 1993 to that in 1998?
Your answer should be compact. 1.01. What is the ratio of the Total Labor Force (in %) in Cameroon in 1993 to that in 1998?
Offer a very short reply. 1.02. What is the ratio of the Total Labor Force (in %) in Cyprus in 1993 to that in 1998?
Your answer should be very brief. 1.03. What is the ratio of the Total Labor Force (in %) of Liberia in 1993 to that in 1998?
Offer a terse response. 1.02. What is the ratio of the Total Labor Force (in %) of Lower middle income in 1993 to that in 1999?
Ensure brevity in your answer.  1.01. What is the ratio of the Total Labor Force (in %) of Cameroon in 1993 to that in 1999?
Provide a succinct answer. 1.02. What is the ratio of the Total Labor Force (in %) in Cyprus in 1993 to that in 1999?
Offer a terse response. 1.03. What is the ratio of the Total Labor Force (in %) of Liberia in 1993 to that in 1999?
Ensure brevity in your answer.  1.02. What is the ratio of the Total Labor Force (in %) in Lower middle income in 1993 to that in 2000?
Your answer should be very brief. 1.01. What is the ratio of the Total Labor Force (in %) in Cameroon in 1993 to that in 2000?
Your answer should be very brief. 1.03. What is the ratio of the Total Labor Force (in %) in Cyprus in 1993 to that in 2000?
Keep it short and to the point. 0.99. What is the ratio of the Total Labor Force (in %) in Liberia in 1993 to that in 2000?
Offer a terse response. 1.02. What is the ratio of the Total Labor Force (in %) of Cameroon in 1994 to that in 1995?
Make the answer very short. 1.01. What is the ratio of the Total Labor Force (in %) in Cyprus in 1994 to that in 1995?
Give a very brief answer. 1. What is the ratio of the Total Labor Force (in %) of Liberia in 1994 to that in 1995?
Provide a short and direct response. 1. What is the ratio of the Total Labor Force (in %) in Cameroon in 1994 to that in 1996?
Give a very brief answer. 1.01. What is the ratio of the Total Labor Force (in %) of Cameroon in 1994 to that in 1997?
Provide a short and direct response. 1.02. What is the ratio of the Total Labor Force (in %) of Liberia in 1994 to that in 1997?
Your answer should be compact. 1.01. What is the ratio of the Total Labor Force (in %) of Cameroon in 1994 to that in 1998?
Ensure brevity in your answer.  1.02. What is the ratio of the Total Labor Force (in %) of Cyprus in 1994 to that in 1998?
Your answer should be compact. 1.01. What is the ratio of the Total Labor Force (in %) of Liberia in 1994 to that in 1998?
Provide a succinct answer. 1.01. What is the ratio of the Total Labor Force (in %) in Lower middle income in 1994 to that in 1999?
Provide a succinct answer. 1.01. What is the ratio of the Total Labor Force (in %) of Cameroon in 1994 to that in 1999?
Ensure brevity in your answer.  1.02. What is the ratio of the Total Labor Force (in %) in Cyprus in 1994 to that in 1999?
Ensure brevity in your answer.  1.02. What is the ratio of the Total Labor Force (in %) in Liberia in 1994 to that in 1999?
Offer a terse response. 1.02. What is the ratio of the Total Labor Force (in %) in Lower middle income in 1994 to that in 2000?
Provide a succinct answer. 1.01. What is the ratio of the Total Labor Force (in %) in Cameroon in 1994 to that in 2000?
Offer a terse response. 1.02. What is the ratio of the Total Labor Force (in %) of Liberia in 1994 to that in 2000?
Your response must be concise. 1.02. What is the ratio of the Total Labor Force (in %) in Cameroon in 1995 to that in 1996?
Offer a terse response. 1.01. What is the ratio of the Total Labor Force (in %) of Lower middle income in 1995 to that in 1997?
Offer a very short reply. 1.01. What is the ratio of the Total Labor Force (in %) of Cameroon in 1995 to that in 1997?
Keep it short and to the point. 1.01. What is the ratio of the Total Labor Force (in %) in Liberia in 1995 to that in 1997?
Provide a succinct answer. 1.01. What is the ratio of the Total Labor Force (in %) in Lower middle income in 1995 to that in 1998?
Provide a short and direct response. 1.01. What is the ratio of the Total Labor Force (in %) in Cameroon in 1995 to that in 1998?
Offer a very short reply. 1.01. What is the ratio of the Total Labor Force (in %) of Cyprus in 1995 to that in 1998?
Offer a terse response. 1.01. What is the ratio of the Total Labor Force (in %) of Liberia in 1995 to that in 1998?
Your answer should be compact. 1.01. What is the ratio of the Total Labor Force (in %) in Cameroon in 1995 to that in 1999?
Your answer should be very brief. 1.01. What is the ratio of the Total Labor Force (in %) in Cyprus in 1995 to that in 1999?
Provide a short and direct response. 1.01. What is the ratio of the Total Labor Force (in %) of Liberia in 1995 to that in 1999?
Ensure brevity in your answer.  1.01. What is the ratio of the Total Labor Force (in %) in Lower middle income in 1995 to that in 2000?
Your answer should be very brief. 1.01. What is the ratio of the Total Labor Force (in %) in Cameroon in 1995 to that in 2000?
Your answer should be very brief. 1.01. What is the ratio of the Total Labor Force (in %) in Cyprus in 1995 to that in 2000?
Ensure brevity in your answer.  0.97. What is the ratio of the Total Labor Force (in %) in Liberia in 1995 to that in 2000?
Give a very brief answer. 1.01. What is the ratio of the Total Labor Force (in %) in Lower middle income in 1996 to that in 1997?
Keep it short and to the point. 1. What is the ratio of the Total Labor Force (in %) in Cameroon in 1996 to that in 1997?
Make the answer very short. 1. What is the ratio of the Total Labor Force (in %) in Cyprus in 1996 to that in 1997?
Your answer should be compact. 1.01. What is the ratio of the Total Labor Force (in %) in Lower middle income in 1996 to that in 1998?
Offer a very short reply. 1.01. What is the ratio of the Total Labor Force (in %) in Cyprus in 1996 to that in 1998?
Your answer should be very brief. 1.02. What is the ratio of the Total Labor Force (in %) of Liberia in 1996 to that in 1998?
Offer a terse response. 1.01. What is the ratio of the Total Labor Force (in %) in Lower middle income in 1996 to that in 1999?
Your answer should be compact. 1.01. What is the ratio of the Total Labor Force (in %) of Cameroon in 1996 to that in 1999?
Provide a short and direct response. 1.01. What is the ratio of the Total Labor Force (in %) in Cyprus in 1996 to that in 1999?
Offer a terse response. 1.02. What is the ratio of the Total Labor Force (in %) in Lower middle income in 1996 to that in 2000?
Offer a terse response. 1.01. What is the ratio of the Total Labor Force (in %) of Cyprus in 1996 to that in 2000?
Your answer should be very brief. 0.98. What is the ratio of the Total Labor Force (in %) in Liberia in 1996 to that in 2000?
Your answer should be compact. 1.01. What is the ratio of the Total Labor Force (in %) of Lower middle income in 1997 to that in 1998?
Your response must be concise. 1. What is the ratio of the Total Labor Force (in %) in Cameroon in 1997 to that in 1998?
Give a very brief answer. 1. What is the ratio of the Total Labor Force (in %) of Liberia in 1997 to that in 1998?
Offer a very short reply. 1. What is the ratio of the Total Labor Force (in %) of Cameroon in 1997 to that in 1999?
Your answer should be compact. 1. What is the ratio of the Total Labor Force (in %) of Cyprus in 1997 to that in 1999?
Your answer should be compact. 1.01. What is the ratio of the Total Labor Force (in %) in Liberia in 1997 to that in 1999?
Ensure brevity in your answer.  1. What is the ratio of the Total Labor Force (in %) of Lower middle income in 1997 to that in 2000?
Your response must be concise. 1.01. What is the ratio of the Total Labor Force (in %) in Cameroon in 1997 to that in 2000?
Your answer should be compact. 1.01. What is the ratio of the Total Labor Force (in %) of Cyprus in 1997 to that in 2000?
Make the answer very short. 0.97. What is the ratio of the Total Labor Force (in %) in Liberia in 1997 to that in 2000?
Offer a terse response. 1.01. What is the ratio of the Total Labor Force (in %) in Lower middle income in 1998 to that in 1999?
Provide a short and direct response. 1. What is the ratio of the Total Labor Force (in %) of Cameroon in 1998 to that in 1999?
Keep it short and to the point. 1. What is the ratio of the Total Labor Force (in %) of Cyprus in 1998 to that in 1999?
Give a very brief answer. 1. What is the ratio of the Total Labor Force (in %) of Cameroon in 1998 to that in 2000?
Keep it short and to the point. 1. What is the ratio of the Total Labor Force (in %) of Cyprus in 1998 to that in 2000?
Provide a succinct answer. 0.96. What is the ratio of the Total Labor Force (in %) of Cyprus in 1999 to that in 2000?
Offer a terse response. 0.96. What is the difference between the highest and the second highest Total Labor Force (in %) in Lower middle income?
Provide a succinct answer. 0.19. What is the difference between the highest and the lowest Total Labor Force (in %) of Lower middle income?
Your answer should be very brief. 1.17. What is the difference between the highest and the lowest Total Labor Force (in %) in Cameroon?
Your response must be concise. 2. 